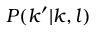Convert formula to latex. <formula><loc_0><loc_0><loc_500><loc_500>P ( k ^ { \prime } | k , l )</formula> 